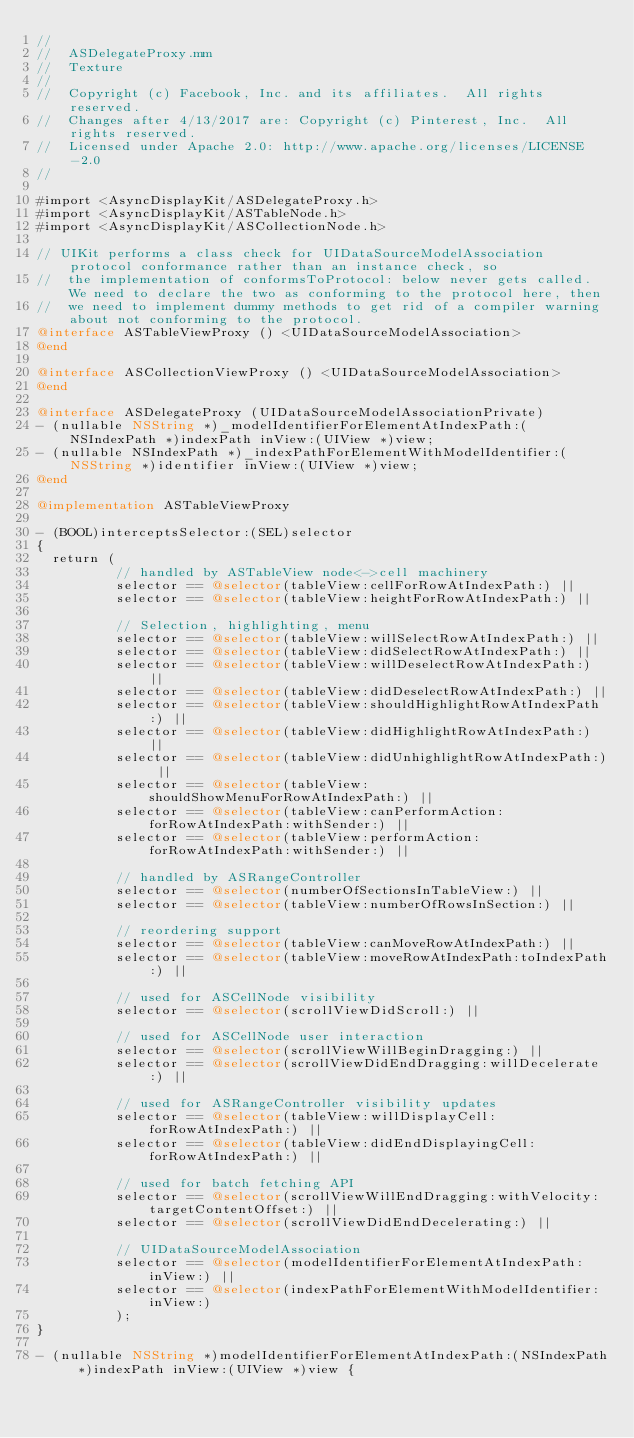<code> <loc_0><loc_0><loc_500><loc_500><_ObjectiveC_>//
//  ASDelegateProxy.mm
//  Texture
//
//  Copyright (c) Facebook, Inc. and its affiliates.  All rights reserved.
//  Changes after 4/13/2017 are: Copyright (c) Pinterest, Inc.  All rights reserved.
//  Licensed under Apache 2.0: http://www.apache.org/licenses/LICENSE-2.0
//

#import <AsyncDisplayKit/ASDelegateProxy.h>
#import <AsyncDisplayKit/ASTableNode.h>
#import <AsyncDisplayKit/ASCollectionNode.h>

// UIKit performs a class check for UIDataSourceModelAssociation protocol conformance rather than an instance check, so
//  the implementation of conformsToProtocol: below never gets called. We need to declare the two as conforming to the protocol here, then
//  we need to implement dummy methods to get rid of a compiler warning about not conforming to the protocol.
@interface ASTableViewProxy () <UIDataSourceModelAssociation>
@end

@interface ASCollectionViewProxy () <UIDataSourceModelAssociation>
@end

@interface ASDelegateProxy (UIDataSourceModelAssociationPrivate)
- (nullable NSString *)_modelIdentifierForElementAtIndexPath:(NSIndexPath *)indexPath inView:(UIView *)view;
- (nullable NSIndexPath *)_indexPathForElementWithModelIdentifier:(NSString *)identifier inView:(UIView *)view;
@end

@implementation ASTableViewProxy

- (BOOL)interceptsSelector:(SEL)selector
{
  return (
          // handled by ASTableView node<->cell machinery
          selector == @selector(tableView:cellForRowAtIndexPath:) ||
          selector == @selector(tableView:heightForRowAtIndexPath:) ||
          
          // Selection, highlighting, menu
          selector == @selector(tableView:willSelectRowAtIndexPath:) ||
          selector == @selector(tableView:didSelectRowAtIndexPath:) ||
          selector == @selector(tableView:willDeselectRowAtIndexPath:) ||
          selector == @selector(tableView:didDeselectRowAtIndexPath:) ||
          selector == @selector(tableView:shouldHighlightRowAtIndexPath:) ||
          selector == @selector(tableView:didHighlightRowAtIndexPath:) ||
          selector == @selector(tableView:didUnhighlightRowAtIndexPath:) ||
          selector == @selector(tableView:shouldShowMenuForRowAtIndexPath:) ||
          selector == @selector(tableView:canPerformAction:forRowAtIndexPath:withSender:) ||
          selector == @selector(tableView:performAction:forRowAtIndexPath:withSender:) ||

          // handled by ASRangeController
          selector == @selector(numberOfSectionsInTableView:) ||
          selector == @selector(tableView:numberOfRowsInSection:) ||

          // reordering support
          selector == @selector(tableView:canMoveRowAtIndexPath:) ||
          selector == @selector(tableView:moveRowAtIndexPath:toIndexPath:) ||
          
          // used for ASCellNode visibility
          selector == @selector(scrollViewDidScroll:) ||

          // used for ASCellNode user interaction
          selector == @selector(scrollViewWillBeginDragging:) ||
          selector == @selector(scrollViewDidEndDragging:willDecelerate:) ||
          
          // used for ASRangeController visibility updates
          selector == @selector(tableView:willDisplayCell:forRowAtIndexPath:) ||
          selector == @selector(tableView:didEndDisplayingCell:forRowAtIndexPath:) ||
          
          // used for batch fetching API
          selector == @selector(scrollViewWillEndDragging:withVelocity:targetContentOffset:) ||
          selector == @selector(scrollViewDidEndDecelerating:) ||

          // UIDataSourceModelAssociation
          selector == @selector(modelIdentifierForElementAtIndexPath:inView:) ||
          selector == @selector(indexPathForElementWithModelIdentifier:inView:)
          );
}

- (nullable NSString *)modelIdentifierForElementAtIndexPath:(NSIndexPath *)indexPath inView:(UIView *)view {</code> 